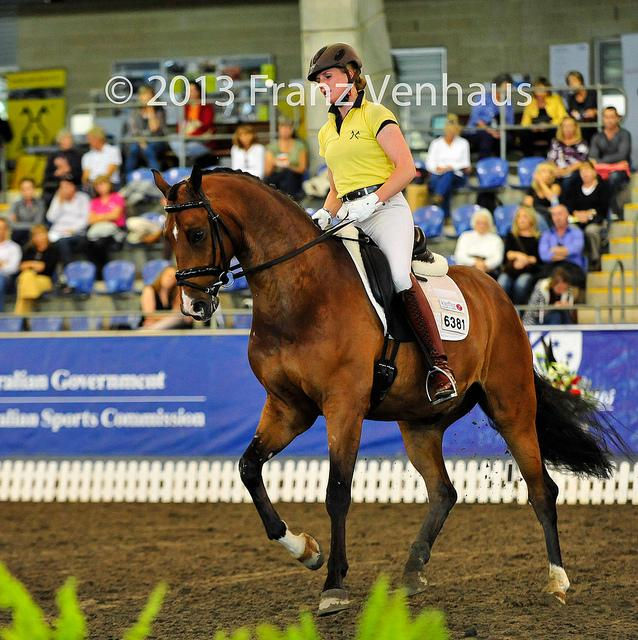What is the woman in yellow doing on the horse? Please explain your reasoning. competing. The woman competes. 